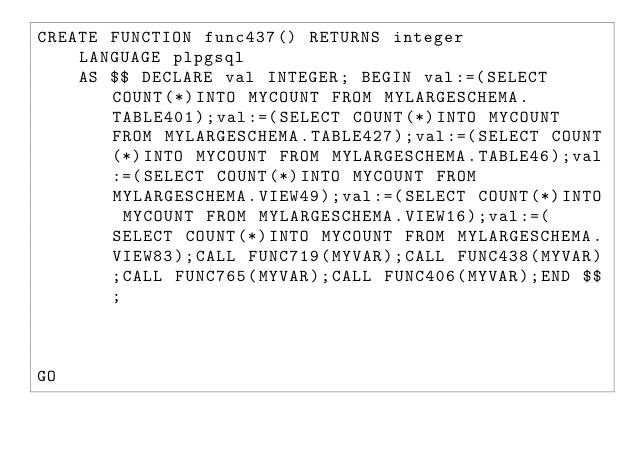Convert code to text. <code><loc_0><loc_0><loc_500><loc_500><_SQL_>CREATE FUNCTION func437() RETURNS integer
    LANGUAGE plpgsql
    AS $$ DECLARE val INTEGER; BEGIN val:=(SELECT COUNT(*)INTO MYCOUNT FROM MYLARGESCHEMA.TABLE401);val:=(SELECT COUNT(*)INTO MYCOUNT FROM MYLARGESCHEMA.TABLE427);val:=(SELECT COUNT(*)INTO MYCOUNT FROM MYLARGESCHEMA.TABLE46);val:=(SELECT COUNT(*)INTO MYCOUNT FROM MYLARGESCHEMA.VIEW49);val:=(SELECT COUNT(*)INTO MYCOUNT FROM MYLARGESCHEMA.VIEW16);val:=(SELECT COUNT(*)INTO MYCOUNT FROM MYLARGESCHEMA.VIEW83);CALL FUNC719(MYVAR);CALL FUNC438(MYVAR);CALL FUNC765(MYVAR);CALL FUNC406(MYVAR);END $$;



GO</code> 